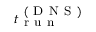<formula> <loc_0><loc_0><loc_500><loc_500>t _ { r u n } ^ { ( D N S ) }</formula> 